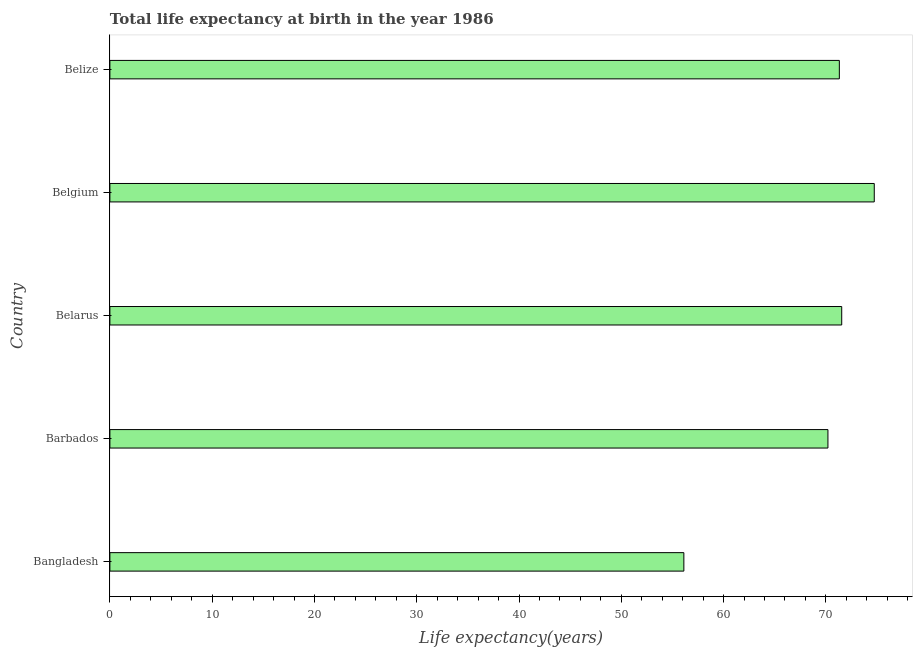Does the graph contain any zero values?
Ensure brevity in your answer.  No. What is the title of the graph?
Offer a terse response. Total life expectancy at birth in the year 1986. What is the label or title of the X-axis?
Provide a succinct answer. Life expectancy(years). What is the label or title of the Y-axis?
Keep it short and to the point. Country. What is the life expectancy at birth in Belarus?
Provide a short and direct response. 71.55. Across all countries, what is the maximum life expectancy at birth?
Your response must be concise. 74.73. Across all countries, what is the minimum life expectancy at birth?
Your response must be concise. 56.12. What is the sum of the life expectancy at birth?
Offer a terse response. 343.92. What is the difference between the life expectancy at birth in Barbados and Belgium?
Your answer should be compact. -4.53. What is the average life expectancy at birth per country?
Provide a succinct answer. 68.78. What is the median life expectancy at birth?
Give a very brief answer. 71.32. What is the difference between the highest and the second highest life expectancy at birth?
Provide a succinct answer. 3.18. Is the sum of the life expectancy at birth in Bangladesh and Belize greater than the maximum life expectancy at birth across all countries?
Give a very brief answer. Yes. What is the difference between the highest and the lowest life expectancy at birth?
Offer a very short reply. 18.62. In how many countries, is the life expectancy at birth greater than the average life expectancy at birth taken over all countries?
Keep it short and to the point. 4. How many bars are there?
Provide a succinct answer. 5. What is the difference between two consecutive major ticks on the X-axis?
Your answer should be very brief. 10. What is the Life expectancy(years) of Bangladesh?
Your answer should be very brief. 56.12. What is the Life expectancy(years) of Barbados?
Ensure brevity in your answer.  70.2. What is the Life expectancy(years) in Belarus?
Keep it short and to the point. 71.55. What is the Life expectancy(years) in Belgium?
Your answer should be compact. 74.73. What is the Life expectancy(years) in Belize?
Offer a very short reply. 71.32. What is the difference between the Life expectancy(years) in Bangladesh and Barbados?
Keep it short and to the point. -14.09. What is the difference between the Life expectancy(years) in Bangladesh and Belarus?
Your response must be concise. -15.43. What is the difference between the Life expectancy(years) in Bangladesh and Belgium?
Provide a succinct answer. -18.62. What is the difference between the Life expectancy(years) in Bangladesh and Belize?
Your answer should be very brief. -15.2. What is the difference between the Life expectancy(years) in Barbados and Belarus?
Your answer should be very brief. -1.35. What is the difference between the Life expectancy(years) in Barbados and Belgium?
Make the answer very short. -4.53. What is the difference between the Life expectancy(years) in Barbados and Belize?
Provide a succinct answer. -1.12. What is the difference between the Life expectancy(years) in Belarus and Belgium?
Offer a very short reply. -3.18. What is the difference between the Life expectancy(years) in Belarus and Belize?
Provide a succinct answer. 0.23. What is the difference between the Life expectancy(years) in Belgium and Belize?
Offer a very short reply. 3.41. What is the ratio of the Life expectancy(years) in Bangladesh to that in Barbados?
Provide a short and direct response. 0.8. What is the ratio of the Life expectancy(years) in Bangladesh to that in Belarus?
Give a very brief answer. 0.78. What is the ratio of the Life expectancy(years) in Bangladesh to that in Belgium?
Give a very brief answer. 0.75. What is the ratio of the Life expectancy(years) in Bangladesh to that in Belize?
Offer a very short reply. 0.79. What is the ratio of the Life expectancy(years) in Barbados to that in Belgium?
Keep it short and to the point. 0.94. What is the ratio of the Life expectancy(years) in Barbados to that in Belize?
Offer a terse response. 0.98. What is the ratio of the Life expectancy(years) in Belarus to that in Belize?
Give a very brief answer. 1. What is the ratio of the Life expectancy(years) in Belgium to that in Belize?
Your response must be concise. 1.05. 